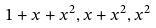Convert formula to latex. <formula><loc_0><loc_0><loc_500><loc_500>1 + x + x ^ { 2 } , x + x ^ { 2 } , x ^ { 2 }</formula> 